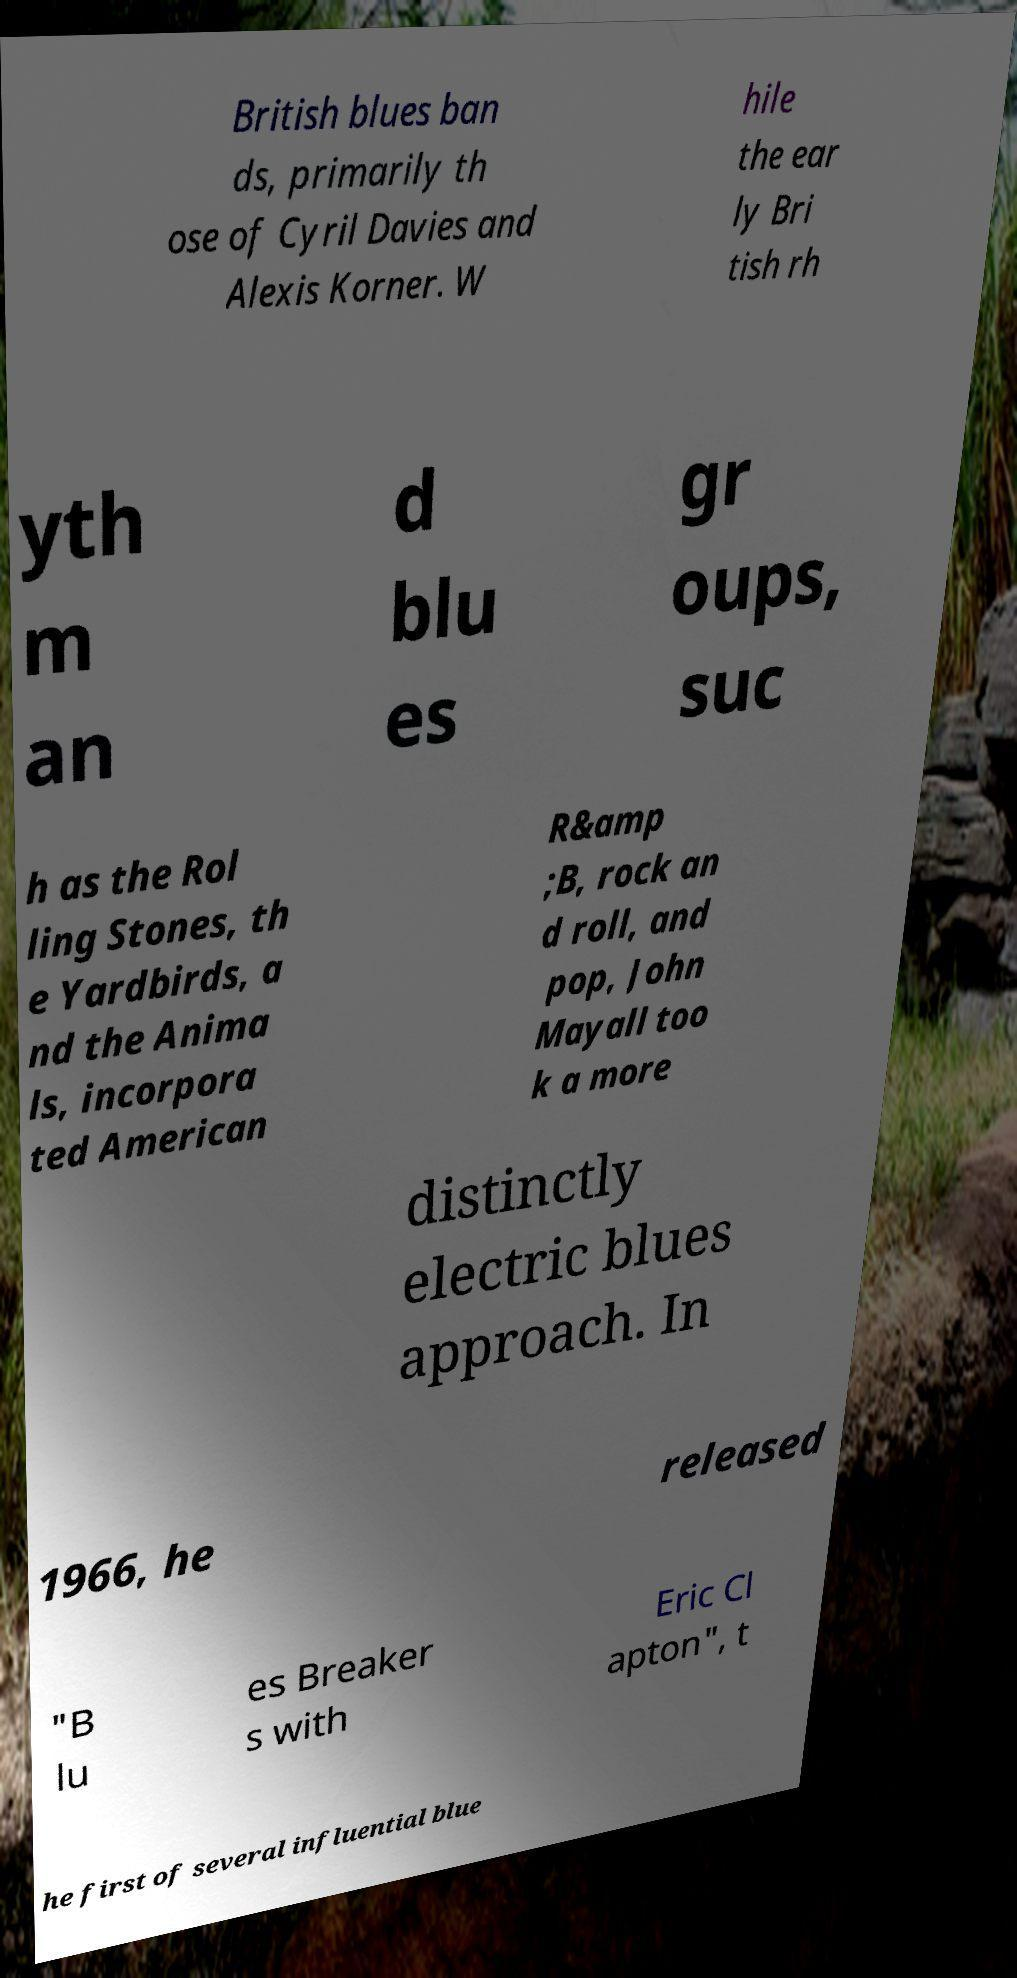Please read and relay the text visible in this image. What does it say? British blues ban ds, primarily th ose of Cyril Davies and Alexis Korner. W hile the ear ly Bri tish rh yth m an d blu es gr oups, suc h as the Rol ling Stones, th e Yardbirds, a nd the Anima ls, incorpora ted American R&amp ;B, rock an d roll, and pop, John Mayall too k a more distinctly electric blues approach. In 1966, he released "B lu es Breaker s with Eric Cl apton", t he first of several influential blue 